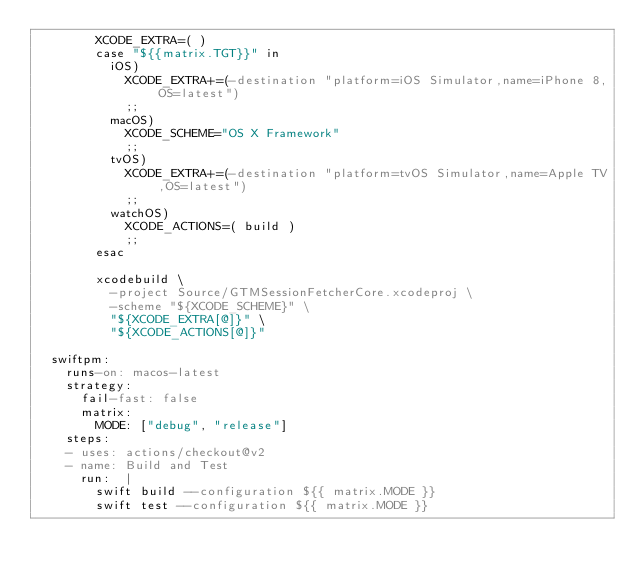Convert code to text. <code><loc_0><loc_0><loc_500><loc_500><_YAML_>        XCODE_EXTRA=( )
        case "${{matrix.TGT}}" in
          iOS)
            XCODE_EXTRA+=(-destination "platform=iOS Simulator,name=iPhone 8,OS=latest")
            ;;
          macOS)
            XCODE_SCHEME="OS X Framework"
            ;;
          tvOS)
            XCODE_EXTRA+=(-destination "platform=tvOS Simulator,name=Apple TV,OS=latest")
            ;;
          watchOS)
            XCODE_ACTIONS=( build )
            ;;
        esac

        xcodebuild \
          -project Source/GTMSessionFetcherCore.xcodeproj \
          -scheme "${XCODE_SCHEME}" \
          "${XCODE_EXTRA[@]}" \
          "${XCODE_ACTIONS[@]}"

  swiftpm:
    runs-on: macos-latest
    strategy:
      fail-fast: false
      matrix:
        MODE: ["debug", "release"]
    steps:
    - uses: actions/checkout@v2
    - name: Build and Test
      run:  |
        swift build --configuration ${{ matrix.MODE }}
        swift test --configuration ${{ matrix.MODE }}
</code> 